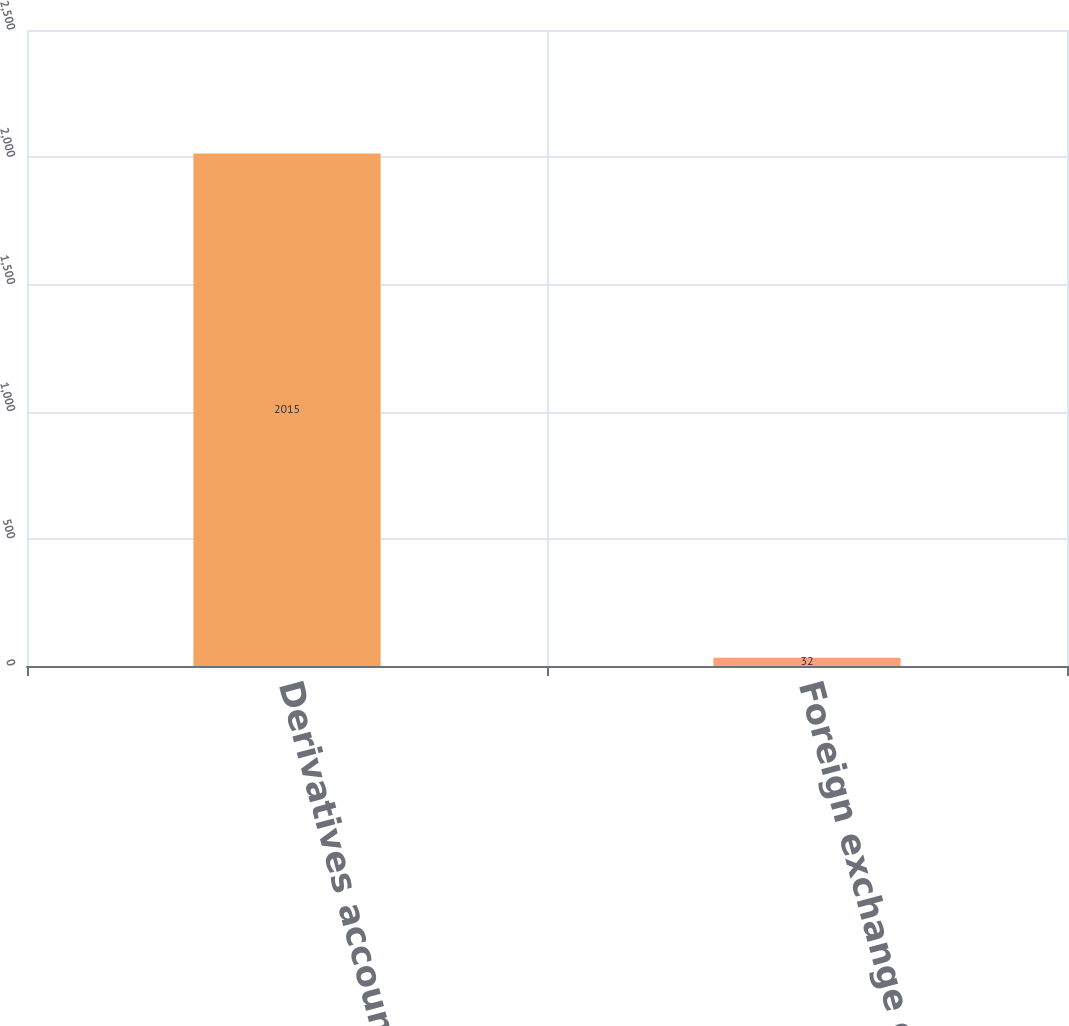Convert chart. <chart><loc_0><loc_0><loc_500><loc_500><bar_chart><fcel>Derivatives accounted for as<fcel>Foreign exchange contracts<nl><fcel>2015<fcel>32<nl></chart> 